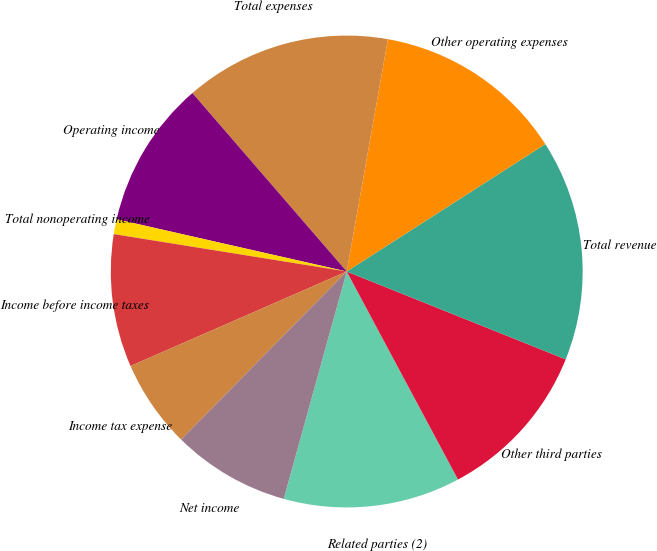Convert chart. <chart><loc_0><loc_0><loc_500><loc_500><pie_chart><fcel>Related parties (2)<fcel>Other third parties<fcel>Total revenue<fcel>Other operating expenses<fcel>Total expenses<fcel>Operating income<fcel>Total nonoperating income<fcel>Income before income taxes<fcel>Income tax expense<fcel>Net income<nl><fcel>12.12%<fcel>11.11%<fcel>15.15%<fcel>13.13%<fcel>14.14%<fcel>10.1%<fcel>1.02%<fcel>9.09%<fcel>6.06%<fcel>8.08%<nl></chart> 